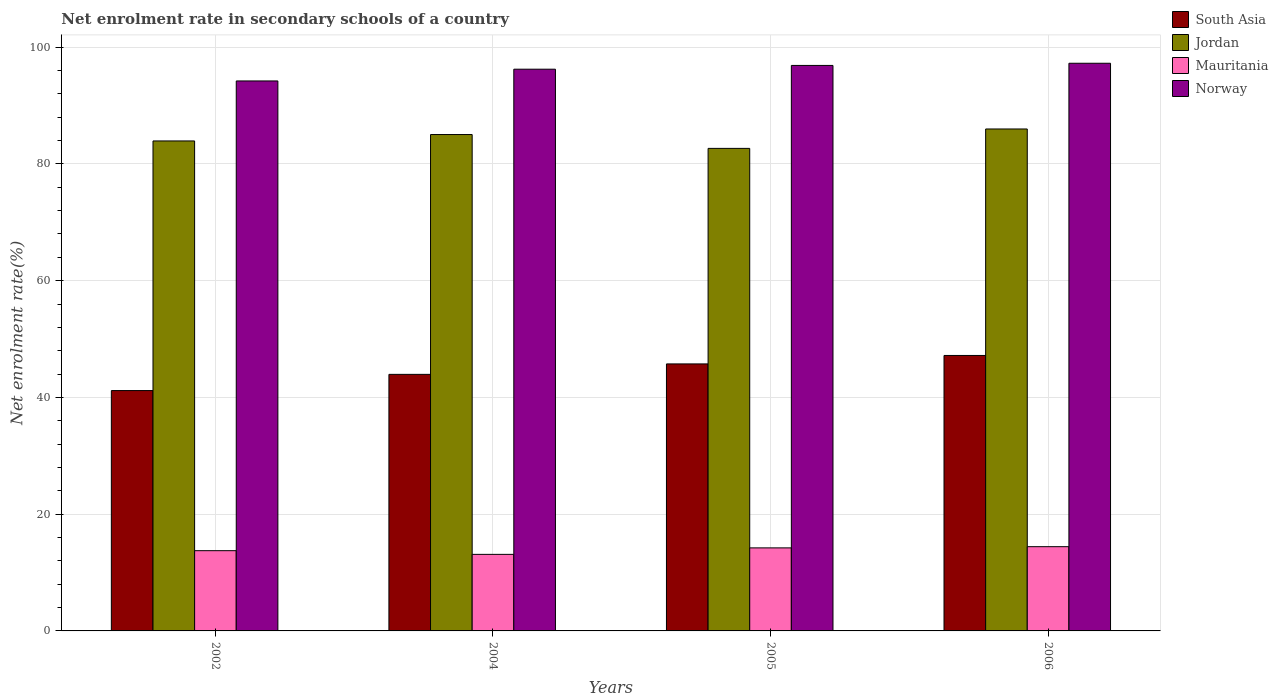Are the number of bars per tick equal to the number of legend labels?
Keep it short and to the point. Yes. How many bars are there on the 1st tick from the left?
Make the answer very short. 4. How many bars are there on the 2nd tick from the right?
Provide a short and direct response. 4. What is the label of the 4th group of bars from the left?
Offer a very short reply. 2006. What is the net enrolment rate in secondary schools in Mauritania in 2005?
Keep it short and to the point. 14.23. Across all years, what is the maximum net enrolment rate in secondary schools in Jordan?
Provide a succinct answer. 85.99. Across all years, what is the minimum net enrolment rate in secondary schools in Jordan?
Your response must be concise. 82.66. In which year was the net enrolment rate in secondary schools in Jordan minimum?
Your answer should be very brief. 2005. What is the total net enrolment rate in secondary schools in Mauritania in the graph?
Your answer should be very brief. 55.52. What is the difference between the net enrolment rate in secondary schools in South Asia in 2004 and that in 2005?
Give a very brief answer. -1.79. What is the difference between the net enrolment rate in secondary schools in South Asia in 2006 and the net enrolment rate in secondary schools in Mauritania in 2004?
Give a very brief answer. 34.07. What is the average net enrolment rate in secondary schools in Mauritania per year?
Your answer should be very brief. 13.88. In the year 2004, what is the difference between the net enrolment rate in secondary schools in Norway and net enrolment rate in secondary schools in Jordan?
Provide a succinct answer. 11.19. In how many years, is the net enrolment rate in secondary schools in Norway greater than 88 %?
Give a very brief answer. 4. What is the ratio of the net enrolment rate in secondary schools in Norway in 2004 to that in 2005?
Your response must be concise. 0.99. Is the net enrolment rate in secondary schools in Mauritania in 2004 less than that in 2006?
Provide a short and direct response. Yes. What is the difference between the highest and the second highest net enrolment rate in secondary schools in Jordan?
Your answer should be compact. 0.95. What is the difference between the highest and the lowest net enrolment rate in secondary schools in South Asia?
Offer a terse response. 6.01. In how many years, is the net enrolment rate in secondary schools in South Asia greater than the average net enrolment rate in secondary schools in South Asia taken over all years?
Provide a succinct answer. 2. Is the sum of the net enrolment rate in secondary schools in South Asia in 2002 and 2006 greater than the maximum net enrolment rate in secondary schools in Jordan across all years?
Your answer should be compact. Yes. What does the 4th bar from the right in 2004 represents?
Offer a very short reply. South Asia. Is it the case that in every year, the sum of the net enrolment rate in secondary schools in Jordan and net enrolment rate in secondary schools in Mauritania is greater than the net enrolment rate in secondary schools in Norway?
Your response must be concise. Yes. How many bars are there?
Provide a short and direct response. 16. How many years are there in the graph?
Provide a succinct answer. 4. Does the graph contain any zero values?
Provide a short and direct response. No. Does the graph contain grids?
Keep it short and to the point. Yes. Where does the legend appear in the graph?
Your answer should be very brief. Top right. How many legend labels are there?
Make the answer very short. 4. What is the title of the graph?
Your answer should be compact. Net enrolment rate in secondary schools of a country. Does "Gambia, The" appear as one of the legend labels in the graph?
Keep it short and to the point. No. What is the label or title of the Y-axis?
Your answer should be compact. Net enrolment rate(%). What is the Net enrolment rate(%) in South Asia in 2002?
Give a very brief answer. 41.18. What is the Net enrolment rate(%) in Jordan in 2002?
Ensure brevity in your answer.  83.94. What is the Net enrolment rate(%) of Mauritania in 2002?
Give a very brief answer. 13.75. What is the Net enrolment rate(%) of Norway in 2002?
Provide a short and direct response. 94.22. What is the Net enrolment rate(%) of South Asia in 2004?
Offer a very short reply. 43.95. What is the Net enrolment rate(%) of Jordan in 2004?
Offer a terse response. 85.04. What is the Net enrolment rate(%) of Mauritania in 2004?
Keep it short and to the point. 13.11. What is the Net enrolment rate(%) in Norway in 2004?
Provide a succinct answer. 96.23. What is the Net enrolment rate(%) of South Asia in 2005?
Your response must be concise. 45.74. What is the Net enrolment rate(%) of Jordan in 2005?
Ensure brevity in your answer.  82.66. What is the Net enrolment rate(%) in Mauritania in 2005?
Offer a very short reply. 14.23. What is the Net enrolment rate(%) in Norway in 2005?
Your response must be concise. 96.88. What is the Net enrolment rate(%) of South Asia in 2006?
Offer a very short reply. 47.19. What is the Net enrolment rate(%) of Jordan in 2006?
Offer a very short reply. 85.99. What is the Net enrolment rate(%) of Mauritania in 2006?
Your answer should be compact. 14.43. What is the Net enrolment rate(%) of Norway in 2006?
Provide a succinct answer. 97.25. Across all years, what is the maximum Net enrolment rate(%) in South Asia?
Provide a short and direct response. 47.19. Across all years, what is the maximum Net enrolment rate(%) in Jordan?
Make the answer very short. 85.99. Across all years, what is the maximum Net enrolment rate(%) of Mauritania?
Give a very brief answer. 14.43. Across all years, what is the maximum Net enrolment rate(%) in Norway?
Provide a short and direct response. 97.25. Across all years, what is the minimum Net enrolment rate(%) of South Asia?
Keep it short and to the point. 41.18. Across all years, what is the minimum Net enrolment rate(%) in Jordan?
Keep it short and to the point. 82.66. Across all years, what is the minimum Net enrolment rate(%) of Mauritania?
Provide a short and direct response. 13.11. Across all years, what is the minimum Net enrolment rate(%) in Norway?
Offer a terse response. 94.22. What is the total Net enrolment rate(%) in South Asia in the graph?
Your answer should be very brief. 178.06. What is the total Net enrolment rate(%) in Jordan in the graph?
Provide a short and direct response. 337.63. What is the total Net enrolment rate(%) of Mauritania in the graph?
Provide a succinct answer. 55.52. What is the total Net enrolment rate(%) of Norway in the graph?
Give a very brief answer. 384.57. What is the difference between the Net enrolment rate(%) of South Asia in 2002 and that in 2004?
Your response must be concise. -2.78. What is the difference between the Net enrolment rate(%) in Jordan in 2002 and that in 2004?
Keep it short and to the point. -1.1. What is the difference between the Net enrolment rate(%) of Mauritania in 2002 and that in 2004?
Your response must be concise. 0.63. What is the difference between the Net enrolment rate(%) in Norway in 2002 and that in 2004?
Your answer should be very brief. -2.01. What is the difference between the Net enrolment rate(%) of South Asia in 2002 and that in 2005?
Offer a very short reply. -4.57. What is the difference between the Net enrolment rate(%) of Jordan in 2002 and that in 2005?
Your answer should be very brief. 1.27. What is the difference between the Net enrolment rate(%) in Mauritania in 2002 and that in 2005?
Make the answer very short. -0.48. What is the difference between the Net enrolment rate(%) in Norway in 2002 and that in 2005?
Offer a very short reply. -2.66. What is the difference between the Net enrolment rate(%) of South Asia in 2002 and that in 2006?
Offer a terse response. -6.01. What is the difference between the Net enrolment rate(%) of Jordan in 2002 and that in 2006?
Provide a succinct answer. -2.05. What is the difference between the Net enrolment rate(%) of Mauritania in 2002 and that in 2006?
Make the answer very short. -0.68. What is the difference between the Net enrolment rate(%) in Norway in 2002 and that in 2006?
Your answer should be very brief. -3.03. What is the difference between the Net enrolment rate(%) of South Asia in 2004 and that in 2005?
Your answer should be compact. -1.79. What is the difference between the Net enrolment rate(%) of Jordan in 2004 and that in 2005?
Provide a short and direct response. 2.37. What is the difference between the Net enrolment rate(%) of Mauritania in 2004 and that in 2005?
Give a very brief answer. -1.11. What is the difference between the Net enrolment rate(%) of Norway in 2004 and that in 2005?
Ensure brevity in your answer.  -0.65. What is the difference between the Net enrolment rate(%) in South Asia in 2004 and that in 2006?
Offer a terse response. -3.24. What is the difference between the Net enrolment rate(%) in Jordan in 2004 and that in 2006?
Make the answer very short. -0.95. What is the difference between the Net enrolment rate(%) of Mauritania in 2004 and that in 2006?
Your answer should be very brief. -1.32. What is the difference between the Net enrolment rate(%) of Norway in 2004 and that in 2006?
Ensure brevity in your answer.  -1.02. What is the difference between the Net enrolment rate(%) of South Asia in 2005 and that in 2006?
Give a very brief answer. -1.45. What is the difference between the Net enrolment rate(%) of Jordan in 2005 and that in 2006?
Your answer should be very brief. -3.32. What is the difference between the Net enrolment rate(%) in Mauritania in 2005 and that in 2006?
Your answer should be very brief. -0.2. What is the difference between the Net enrolment rate(%) of Norway in 2005 and that in 2006?
Your answer should be very brief. -0.37. What is the difference between the Net enrolment rate(%) of South Asia in 2002 and the Net enrolment rate(%) of Jordan in 2004?
Offer a terse response. -43.86. What is the difference between the Net enrolment rate(%) of South Asia in 2002 and the Net enrolment rate(%) of Mauritania in 2004?
Provide a succinct answer. 28.06. What is the difference between the Net enrolment rate(%) in South Asia in 2002 and the Net enrolment rate(%) in Norway in 2004?
Your answer should be very brief. -55.05. What is the difference between the Net enrolment rate(%) of Jordan in 2002 and the Net enrolment rate(%) of Mauritania in 2004?
Offer a terse response. 70.82. What is the difference between the Net enrolment rate(%) of Jordan in 2002 and the Net enrolment rate(%) of Norway in 2004?
Keep it short and to the point. -12.29. What is the difference between the Net enrolment rate(%) of Mauritania in 2002 and the Net enrolment rate(%) of Norway in 2004?
Your answer should be compact. -82.48. What is the difference between the Net enrolment rate(%) in South Asia in 2002 and the Net enrolment rate(%) in Jordan in 2005?
Provide a short and direct response. -41.49. What is the difference between the Net enrolment rate(%) in South Asia in 2002 and the Net enrolment rate(%) in Mauritania in 2005?
Provide a succinct answer. 26.95. What is the difference between the Net enrolment rate(%) in South Asia in 2002 and the Net enrolment rate(%) in Norway in 2005?
Your response must be concise. -55.7. What is the difference between the Net enrolment rate(%) in Jordan in 2002 and the Net enrolment rate(%) in Mauritania in 2005?
Keep it short and to the point. 69.71. What is the difference between the Net enrolment rate(%) of Jordan in 2002 and the Net enrolment rate(%) of Norway in 2005?
Give a very brief answer. -12.94. What is the difference between the Net enrolment rate(%) in Mauritania in 2002 and the Net enrolment rate(%) in Norway in 2005?
Make the answer very short. -83.13. What is the difference between the Net enrolment rate(%) in South Asia in 2002 and the Net enrolment rate(%) in Jordan in 2006?
Give a very brief answer. -44.81. What is the difference between the Net enrolment rate(%) of South Asia in 2002 and the Net enrolment rate(%) of Mauritania in 2006?
Keep it short and to the point. 26.75. What is the difference between the Net enrolment rate(%) in South Asia in 2002 and the Net enrolment rate(%) in Norway in 2006?
Offer a terse response. -56.07. What is the difference between the Net enrolment rate(%) of Jordan in 2002 and the Net enrolment rate(%) of Mauritania in 2006?
Your response must be concise. 69.51. What is the difference between the Net enrolment rate(%) of Jordan in 2002 and the Net enrolment rate(%) of Norway in 2006?
Make the answer very short. -13.31. What is the difference between the Net enrolment rate(%) in Mauritania in 2002 and the Net enrolment rate(%) in Norway in 2006?
Make the answer very short. -83.5. What is the difference between the Net enrolment rate(%) in South Asia in 2004 and the Net enrolment rate(%) in Jordan in 2005?
Offer a very short reply. -38.71. What is the difference between the Net enrolment rate(%) of South Asia in 2004 and the Net enrolment rate(%) of Mauritania in 2005?
Keep it short and to the point. 29.73. What is the difference between the Net enrolment rate(%) in South Asia in 2004 and the Net enrolment rate(%) in Norway in 2005?
Provide a short and direct response. -52.92. What is the difference between the Net enrolment rate(%) of Jordan in 2004 and the Net enrolment rate(%) of Mauritania in 2005?
Provide a succinct answer. 70.81. What is the difference between the Net enrolment rate(%) of Jordan in 2004 and the Net enrolment rate(%) of Norway in 2005?
Your answer should be compact. -11.84. What is the difference between the Net enrolment rate(%) of Mauritania in 2004 and the Net enrolment rate(%) of Norway in 2005?
Offer a very short reply. -83.76. What is the difference between the Net enrolment rate(%) of South Asia in 2004 and the Net enrolment rate(%) of Jordan in 2006?
Your response must be concise. -42.04. What is the difference between the Net enrolment rate(%) of South Asia in 2004 and the Net enrolment rate(%) of Mauritania in 2006?
Ensure brevity in your answer.  29.52. What is the difference between the Net enrolment rate(%) in South Asia in 2004 and the Net enrolment rate(%) in Norway in 2006?
Offer a very short reply. -53.3. What is the difference between the Net enrolment rate(%) in Jordan in 2004 and the Net enrolment rate(%) in Mauritania in 2006?
Provide a short and direct response. 70.61. What is the difference between the Net enrolment rate(%) in Jordan in 2004 and the Net enrolment rate(%) in Norway in 2006?
Keep it short and to the point. -12.21. What is the difference between the Net enrolment rate(%) in Mauritania in 2004 and the Net enrolment rate(%) in Norway in 2006?
Your response must be concise. -84.13. What is the difference between the Net enrolment rate(%) of South Asia in 2005 and the Net enrolment rate(%) of Jordan in 2006?
Make the answer very short. -40.25. What is the difference between the Net enrolment rate(%) in South Asia in 2005 and the Net enrolment rate(%) in Mauritania in 2006?
Offer a terse response. 31.31. What is the difference between the Net enrolment rate(%) in South Asia in 2005 and the Net enrolment rate(%) in Norway in 2006?
Give a very brief answer. -51.51. What is the difference between the Net enrolment rate(%) of Jordan in 2005 and the Net enrolment rate(%) of Mauritania in 2006?
Your response must be concise. 68.23. What is the difference between the Net enrolment rate(%) of Jordan in 2005 and the Net enrolment rate(%) of Norway in 2006?
Your answer should be very brief. -14.58. What is the difference between the Net enrolment rate(%) in Mauritania in 2005 and the Net enrolment rate(%) in Norway in 2006?
Provide a short and direct response. -83.02. What is the average Net enrolment rate(%) of South Asia per year?
Give a very brief answer. 44.51. What is the average Net enrolment rate(%) in Jordan per year?
Offer a terse response. 84.41. What is the average Net enrolment rate(%) in Mauritania per year?
Keep it short and to the point. 13.88. What is the average Net enrolment rate(%) in Norway per year?
Ensure brevity in your answer.  96.14. In the year 2002, what is the difference between the Net enrolment rate(%) in South Asia and Net enrolment rate(%) in Jordan?
Keep it short and to the point. -42.76. In the year 2002, what is the difference between the Net enrolment rate(%) of South Asia and Net enrolment rate(%) of Mauritania?
Make the answer very short. 27.43. In the year 2002, what is the difference between the Net enrolment rate(%) of South Asia and Net enrolment rate(%) of Norway?
Your response must be concise. -53.04. In the year 2002, what is the difference between the Net enrolment rate(%) of Jordan and Net enrolment rate(%) of Mauritania?
Ensure brevity in your answer.  70.19. In the year 2002, what is the difference between the Net enrolment rate(%) of Jordan and Net enrolment rate(%) of Norway?
Keep it short and to the point. -10.28. In the year 2002, what is the difference between the Net enrolment rate(%) of Mauritania and Net enrolment rate(%) of Norway?
Your response must be concise. -80.47. In the year 2004, what is the difference between the Net enrolment rate(%) of South Asia and Net enrolment rate(%) of Jordan?
Make the answer very short. -41.09. In the year 2004, what is the difference between the Net enrolment rate(%) in South Asia and Net enrolment rate(%) in Mauritania?
Keep it short and to the point. 30.84. In the year 2004, what is the difference between the Net enrolment rate(%) of South Asia and Net enrolment rate(%) of Norway?
Offer a terse response. -52.28. In the year 2004, what is the difference between the Net enrolment rate(%) in Jordan and Net enrolment rate(%) in Mauritania?
Your answer should be very brief. 71.92. In the year 2004, what is the difference between the Net enrolment rate(%) of Jordan and Net enrolment rate(%) of Norway?
Provide a succinct answer. -11.19. In the year 2004, what is the difference between the Net enrolment rate(%) of Mauritania and Net enrolment rate(%) of Norway?
Keep it short and to the point. -83.12. In the year 2005, what is the difference between the Net enrolment rate(%) in South Asia and Net enrolment rate(%) in Jordan?
Offer a terse response. -36.92. In the year 2005, what is the difference between the Net enrolment rate(%) in South Asia and Net enrolment rate(%) in Mauritania?
Your response must be concise. 31.52. In the year 2005, what is the difference between the Net enrolment rate(%) of South Asia and Net enrolment rate(%) of Norway?
Give a very brief answer. -51.13. In the year 2005, what is the difference between the Net enrolment rate(%) of Jordan and Net enrolment rate(%) of Mauritania?
Keep it short and to the point. 68.44. In the year 2005, what is the difference between the Net enrolment rate(%) of Jordan and Net enrolment rate(%) of Norway?
Your answer should be compact. -14.21. In the year 2005, what is the difference between the Net enrolment rate(%) of Mauritania and Net enrolment rate(%) of Norway?
Your response must be concise. -82.65. In the year 2006, what is the difference between the Net enrolment rate(%) of South Asia and Net enrolment rate(%) of Jordan?
Offer a very short reply. -38.8. In the year 2006, what is the difference between the Net enrolment rate(%) in South Asia and Net enrolment rate(%) in Mauritania?
Your answer should be very brief. 32.76. In the year 2006, what is the difference between the Net enrolment rate(%) of South Asia and Net enrolment rate(%) of Norway?
Your response must be concise. -50.06. In the year 2006, what is the difference between the Net enrolment rate(%) in Jordan and Net enrolment rate(%) in Mauritania?
Provide a short and direct response. 71.56. In the year 2006, what is the difference between the Net enrolment rate(%) in Jordan and Net enrolment rate(%) in Norway?
Your response must be concise. -11.26. In the year 2006, what is the difference between the Net enrolment rate(%) in Mauritania and Net enrolment rate(%) in Norway?
Your answer should be very brief. -82.82. What is the ratio of the Net enrolment rate(%) of South Asia in 2002 to that in 2004?
Provide a short and direct response. 0.94. What is the ratio of the Net enrolment rate(%) of Jordan in 2002 to that in 2004?
Your answer should be compact. 0.99. What is the ratio of the Net enrolment rate(%) of Mauritania in 2002 to that in 2004?
Provide a succinct answer. 1.05. What is the ratio of the Net enrolment rate(%) in Norway in 2002 to that in 2004?
Your response must be concise. 0.98. What is the ratio of the Net enrolment rate(%) in South Asia in 2002 to that in 2005?
Your response must be concise. 0.9. What is the ratio of the Net enrolment rate(%) of Jordan in 2002 to that in 2005?
Your answer should be very brief. 1.02. What is the ratio of the Net enrolment rate(%) in Mauritania in 2002 to that in 2005?
Provide a short and direct response. 0.97. What is the ratio of the Net enrolment rate(%) of Norway in 2002 to that in 2005?
Keep it short and to the point. 0.97. What is the ratio of the Net enrolment rate(%) in South Asia in 2002 to that in 2006?
Ensure brevity in your answer.  0.87. What is the ratio of the Net enrolment rate(%) of Jordan in 2002 to that in 2006?
Provide a succinct answer. 0.98. What is the ratio of the Net enrolment rate(%) of Mauritania in 2002 to that in 2006?
Your answer should be compact. 0.95. What is the ratio of the Net enrolment rate(%) of Norway in 2002 to that in 2006?
Keep it short and to the point. 0.97. What is the ratio of the Net enrolment rate(%) of South Asia in 2004 to that in 2005?
Offer a very short reply. 0.96. What is the ratio of the Net enrolment rate(%) in Jordan in 2004 to that in 2005?
Give a very brief answer. 1.03. What is the ratio of the Net enrolment rate(%) of Mauritania in 2004 to that in 2005?
Ensure brevity in your answer.  0.92. What is the ratio of the Net enrolment rate(%) of Norway in 2004 to that in 2005?
Give a very brief answer. 0.99. What is the ratio of the Net enrolment rate(%) of South Asia in 2004 to that in 2006?
Offer a very short reply. 0.93. What is the ratio of the Net enrolment rate(%) of Jordan in 2004 to that in 2006?
Your response must be concise. 0.99. What is the ratio of the Net enrolment rate(%) in Mauritania in 2004 to that in 2006?
Your answer should be compact. 0.91. What is the ratio of the Net enrolment rate(%) in Norway in 2004 to that in 2006?
Your answer should be compact. 0.99. What is the ratio of the Net enrolment rate(%) in South Asia in 2005 to that in 2006?
Your answer should be compact. 0.97. What is the ratio of the Net enrolment rate(%) in Jordan in 2005 to that in 2006?
Offer a very short reply. 0.96. What is the ratio of the Net enrolment rate(%) of Mauritania in 2005 to that in 2006?
Provide a short and direct response. 0.99. What is the difference between the highest and the second highest Net enrolment rate(%) in South Asia?
Give a very brief answer. 1.45. What is the difference between the highest and the second highest Net enrolment rate(%) in Jordan?
Offer a very short reply. 0.95. What is the difference between the highest and the second highest Net enrolment rate(%) of Mauritania?
Provide a short and direct response. 0.2. What is the difference between the highest and the second highest Net enrolment rate(%) in Norway?
Keep it short and to the point. 0.37. What is the difference between the highest and the lowest Net enrolment rate(%) of South Asia?
Give a very brief answer. 6.01. What is the difference between the highest and the lowest Net enrolment rate(%) in Jordan?
Your answer should be very brief. 3.32. What is the difference between the highest and the lowest Net enrolment rate(%) in Mauritania?
Ensure brevity in your answer.  1.32. What is the difference between the highest and the lowest Net enrolment rate(%) in Norway?
Your answer should be very brief. 3.03. 